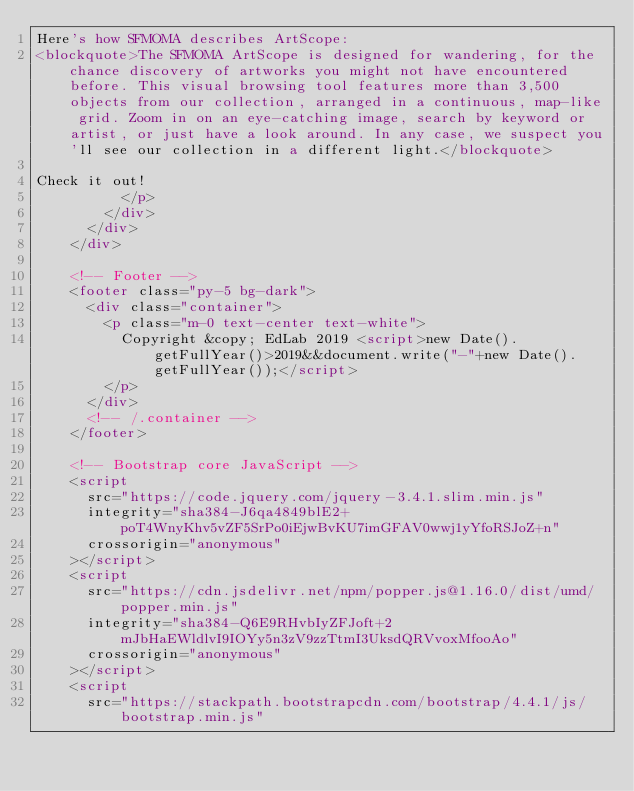<code> <loc_0><loc_0><loc_500><loc_500><_HTML_>Here's how SFMOMA describes ArtScope:
<blockquote>The SFMOMA ArtScope is designed for wandering, for the chance discovery of artworks you might not have encountered before. This visual browsing tool features more than 3,500 objects from our collection, arranged in a continuous, map-like grid. Zoom in on an eye-catching image, search by keyword or artist, or just have a look around. In any case, we suspect you'll see our collection in a different light.</blockquote>

Check it out!
          </p>
        </div>
      </div>
    </div>

    <!-- Footer -->
    <footer class="py-5 bg-dark">
      <div class="container">
        <p class="m-0 text-center text-white">
          Copyright &copy; EdLab 2019 <script>new Date().getFullYear()>2019&&document.write("-"+new Date().getFullYear());</script>
        </p>
      </div>
      <!-- /.container -->
    </footer>

    <!-- Bootstrap core JavaScript -->
    <script
      src="https://code.jquery.com/jquery-3.4.1.slim.min.js"
      integrity="sha384-J6qa4849blE2+poT4WnyKhv5vZF5SrPo0iEjwBvKU7imGFAV0wwj1yYfoRSJoZ+n"
      crossorigin="anonymous"
    ></script>
    <script
      src="https://cdn.jsdelivr.net/npm/popper.js@1.16.0/dist/umd/popper.min.js"
      integrity="sha384-Q6E9RHvbIyZFJoft+2mJbHaEWldlvI9IOYy5n3zV9zzTtmI3UksdQRVvoxMfooAo"
      crossorigin="anonymous"
    ></script>
    <script
      src="https://stackpath.bootstrapcdn.com/bootstrap/4.4.1/js/bootstrap.min.js"</code> 